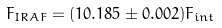Convert formula to latex. <formula><loc_0><loc_0><loc_500><loc_500>F _ { I R A F } = ( 1 0 . 1 8 5 \pm 0 . 0 0 2 ) F _ { i n t }</formula> 